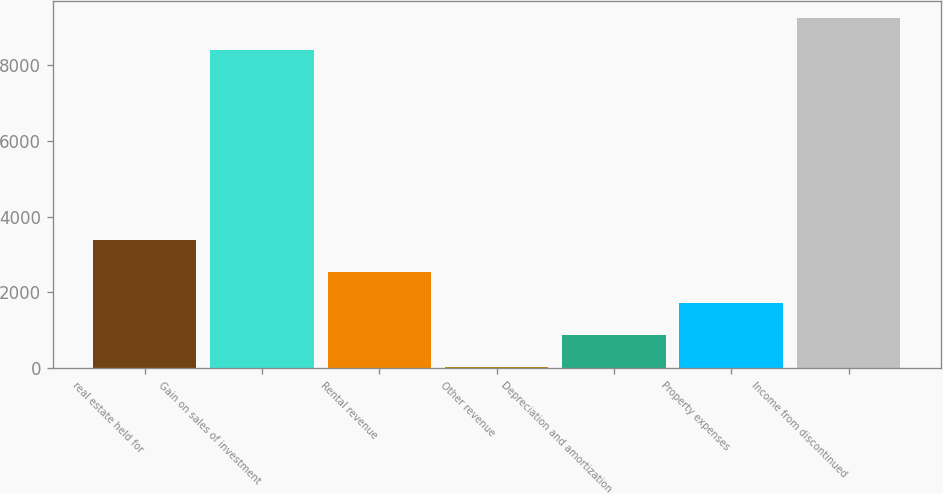Convert chart. <chart><loc_0><loc_0><loc_500><loc_500><bar_chart><fcel>real estate held for<fcel>Gain on sales of investment<fcel>Rental revenue<fcel>Other revenue<fcel>Depreciation and amortization<fcel>Property expenses<fcel>Income from discontinued<nl><fcel>3388<fcel>8405<fcel>2549<fcel>32<fcel>871<fcel>1710<fcel>9244<nl></chart> 